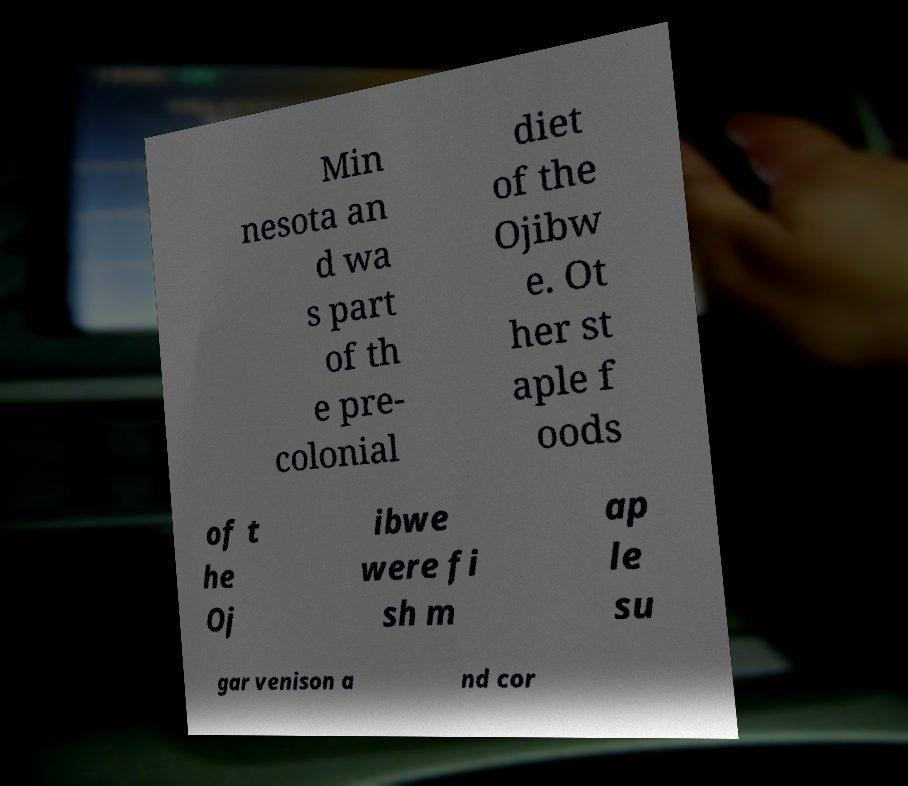Could you assist in decoding the text presented in this image and type it out clearly? Min nesota an d wa s part of th e pre- colonial diet of the Ojibw e. Ot her st aple f oods of t he Oj ibwe were fi sh m ap le su gar venison a nd cor 